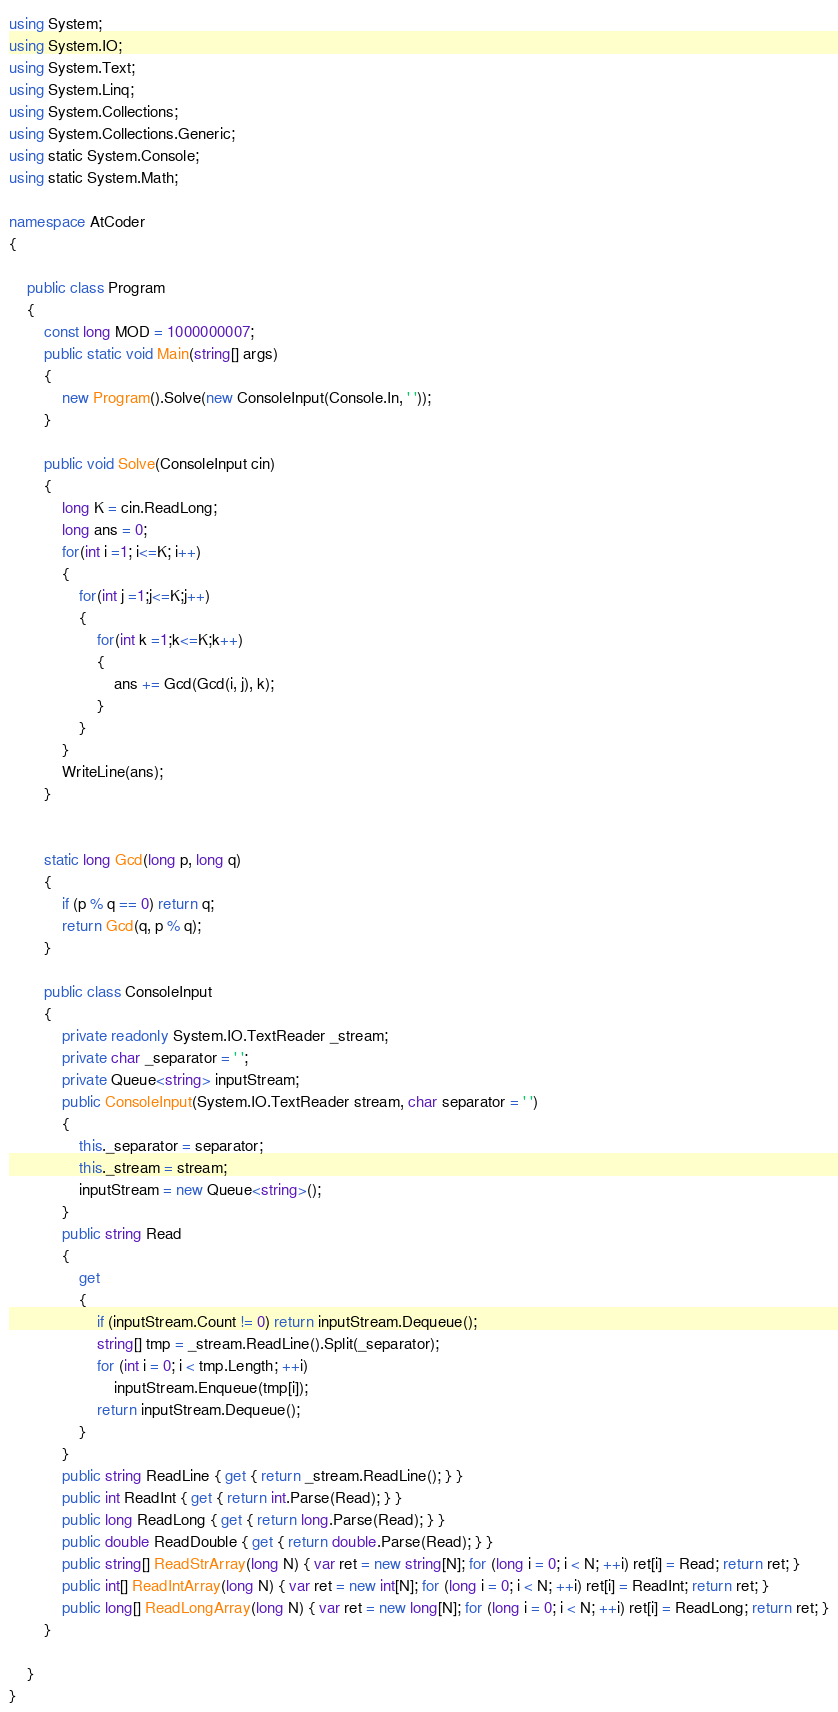<code> <loc_0><loc_0><loc_500><loc_500><_C#_>using System;
using System.IO;
using System.Text;
using System.Linq;
using System.Collections;
using System.Collections.Generic;
using static System.Console;
using static System.Math;

namespace AtCoder
{

    public class Program
    {
        const long MOD = 1000000007;
        public static void Main(string[] args)
        {
            new Program().Solve(new ConsoleInput(Console.In, ' '));
        }

        public void Solve(ConsoleInput cin)
        {
            long K = cin.ReadLong;
            long ans = 0;
            for(int i =1; i<=K; i++)
            {
                for(int j =1;j<=K;j++)
                {
                    for(int k =1;k<=K;k++)
                    {
                        ans += Gcd(Gcd(i, j), k);
                    }
                }
            }
            WriteLine(ans);
        }


        static long Gcd(long p, long q)
        {
            if (p % q == 0) return q;
            return Gcd(q, p % q);
        }

        public class ConsoleInput
        {
            private readonly System.IO.TextReader _stream;
            private char _separator = ' ';
            private Queue<string> inputStream;
            public ConsoleInput(System.IO.TextReader stream, char separator = ' ')
            {
                this._separator = separator;
                this._stream = stream;
                inputStream = new Queue<string>();
            }
            public string Read
            {
                get
                {
                    if (inputStream.Count != 0) return inputStream.Dequeue();
                    string[] tmp = _stream.ReadLine().Split(_separator);
                    for (int i = 0; i < tmp.Length; ++i)
                        inputStream.Enqueue(tmp[i]);
                    return inputStream.Dequeue();
                }
            }
            public string ReadLine { get { return _stream.ReadLine(); } }
            public int ReadInt { get { return int.Parse(Read); } }
            public long ReadLong { get { return long.Parse(Read); } }
            public double ReadDouble { get { return double.Parse(Read); } }
            public string[] ReadStrArray(long N) { var ret = new string[N]; for (long i = 0; i < N; ++i) ret[i] = Read; return ret; }
            public int[] ReadIntArray(long N) { var ret = new int[N]; for (long i = 0; i < N; ++i) ret[i] = ReadInt; return ret; }
            public long[] ReadLongArray(long N) { var ret = new long[N]; for (long i = 0; i < N; ++i) ret[i] = ReadLong; return ret; }
        }

    }
}</code> 